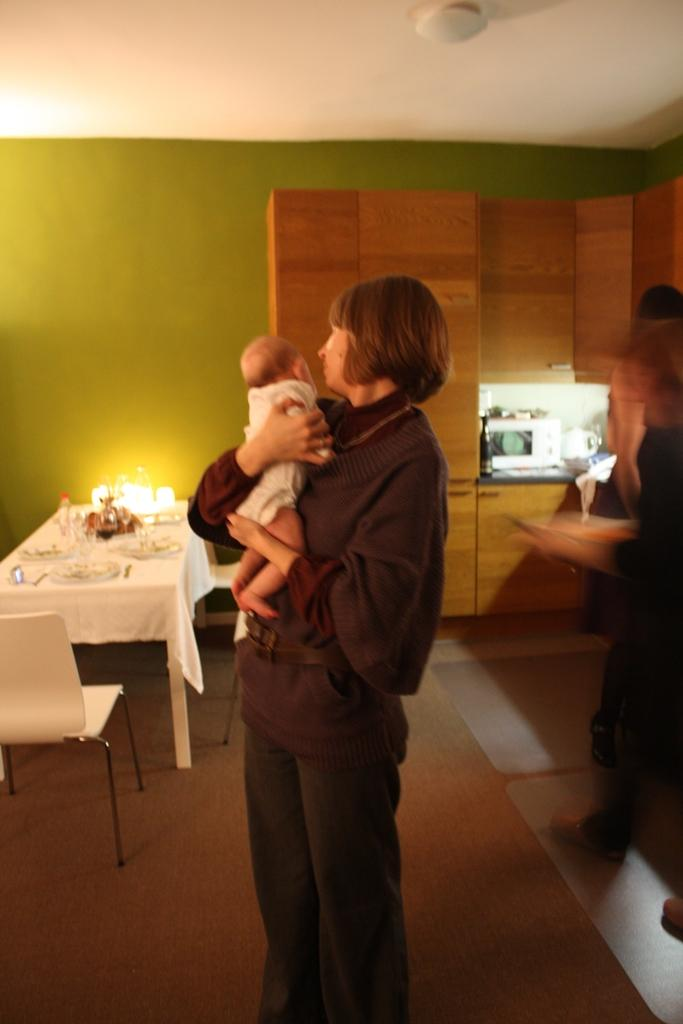Who is the main subject in the image? There is a woman in the image. What is the woman doing in the image? The woman is standing and holding a baby in her hands. What can be seen in the background of the image? There is a table, chairs, and a wall in the background of the image. Where is the robin hiding in the image? There is no robin present in the image. What type of sticks can be seen in the image? There are no sticks visible in the image. 